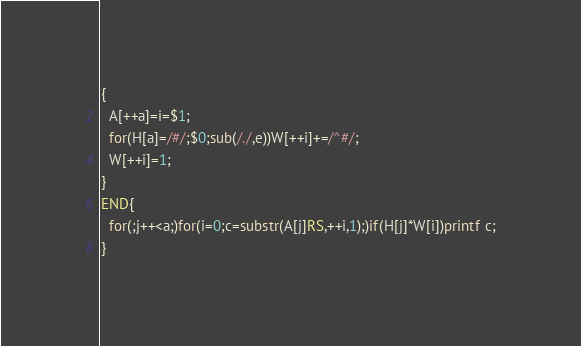Convert code to text. <code><loc_0><loc_0><loc_500><loc_500><_Awk_>{
  A[++a]=i=$1;
  for(H[a]=/#/;$0;sub(/./,e))W[++i]+=/^#/;
  W[++i]=1;
}
END{
  for(;j++<a;)for(i=0;c=substr(A[j]RS,++i,1);)if(H[j]*W[i])printf c;
}</code> 